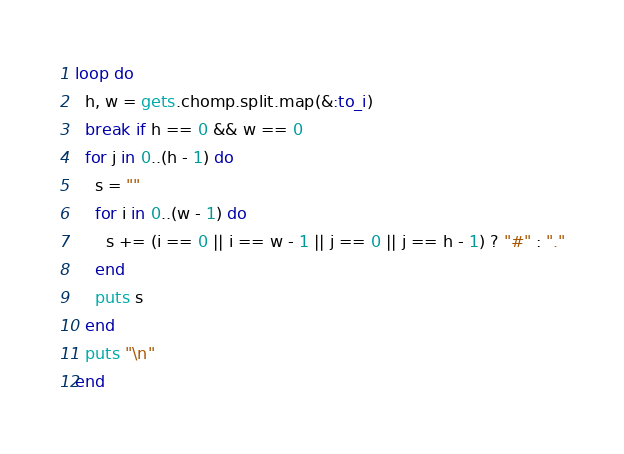<code> <loc_0><loc_0><loc_500><loc_500><_Ruby_>loop do
  h, w = gets.chomp.split.map(&:to_i)
  break if h == 0 && w == 0
  for j in 0..(h - 1) do
    s = ""
    for i in 0..(w - 1) do
      s += (i == 0 || i == w - 1 || j == 0 || j == h - 1) ? "#" : "."
    end
    puts s
  end
  puts "\n"
end
</code> 